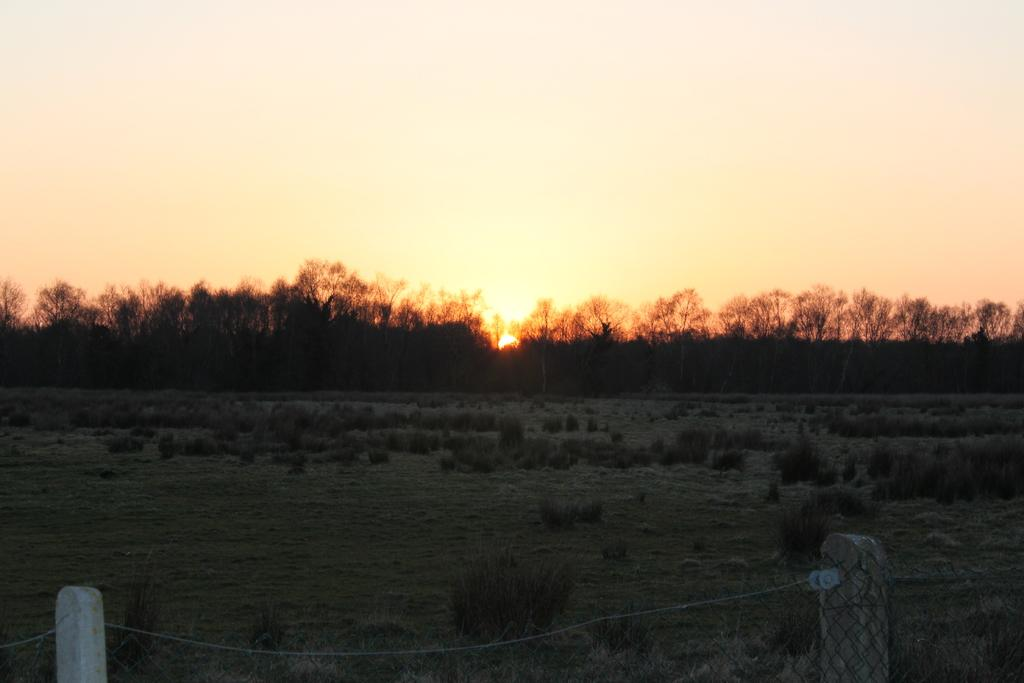What objects are present in the image that are used for support or suspension? There are poles in the image, which are used for support or suspension. What is attached to the poles in the image? There is a rope attached to the poles in the image. What can be seen in the background of the image? There are trees and plants in the background of the image. What is visible at the bottom of the image? The ground is visible at the bottom of the image. What is happening in the sky at the top of the image? There is a sunset in the sky at the top of the image. How many water bottles are visible in the image? There is no mention of water bottles in the provided facts, so we cannot determine their presence or quantity in the image. 